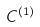<formula> <loc_0><loc_0><loc_500><loc_500>C ^ { ( 1 ) }</formula> 